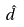<formula> <loc_0><loc_0><loc_500><loc_500>\hat { d }</formula> 